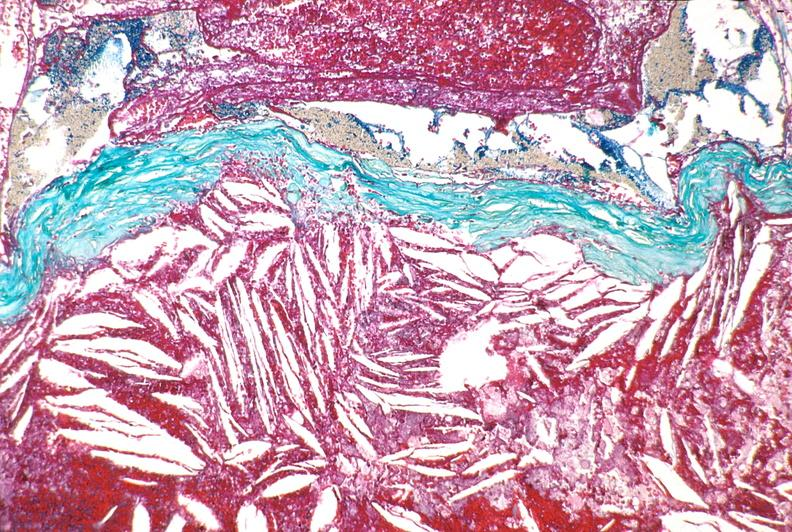where is this from?
Answer the question using a single word or phrase. Vasculature 